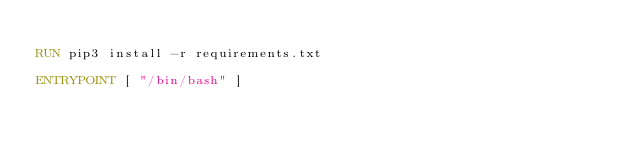<code> <loc_0><loc_0><loc_500><loc_500><_Dockerfile_>
RUN pip3 install -r requirements.txt

ENTRYPOINT [ "/bin/bash" ]</code> 